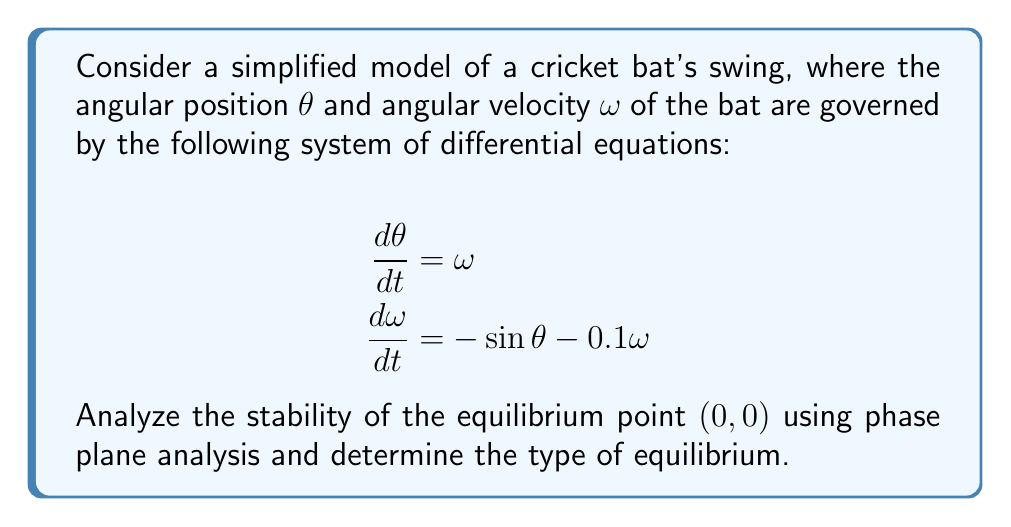What is the answer to this math problem? Let's approach this step-by-step:

1) First, we identify the equilibrium points by setting $\frac{d\theta}{dt} = 0$ and $\frac{d\omega}{dt} = 0$:

   $\omega = 0$
   $-\sin\theta - 0.1\omega = 0$

   This gives us the equilibrium point $(0,0)$ and $(\pi,0)$. We'll focus on $(0,0)$ as per the question.

2) To analyze stability, we need to linearize the system around $(0,0)$. The Jacobian matrix at $(0,0)$ is:

   $$J = \begin{bmatrix}
   \frac{\partial}{\partial\theta}(\omega) & \frac{\partial}{\partial\omega}(\omega) \\
   \frac{\partial}{\partial\theta}(-\sin\theta - 0.1\omega) & \frac{\partial}{\partial\omega}(-\sin\theta - 0.1\omega)
   \end{bmatrix} = \begin{bmatrix}
   0 & 1 \\
   -\cos(0) & -0.1
   \end{bmatrix} = \begin{bmatrix}
   0 & 1 \\
   -1 & -0.1
   \end{bmatrix}$$

3) The characteristic equation is:

   $$\det(J - \lambda I) = \begin{vmatrix}
   -\lambda & 1 \\
   -1 & -0.1-\lambda
   \end{vmatrix} = \lambda^2 + 0.1\lambda + 1 = 0$$

4) Solving this quadratic equation:

   $$\lambda = \frac{-0.1 \pm \sqrt{0.01 - 4}}{2} = -0.05 \pm 0.9987i$$

5) Since the real part of both eigenvalues is negative and the imaginary part is non-zero, this indicates a stable spiral point.

6) In the context of the cricket bat, this means that small perturbations from the equilibrium position (vertical bat at rest) will result in the bat returning to the equilibrium position in a spiraling motion, gradually decreasing in amplitude due to the damping term $-0.1\omega$.
Answer: Stable spiral point 